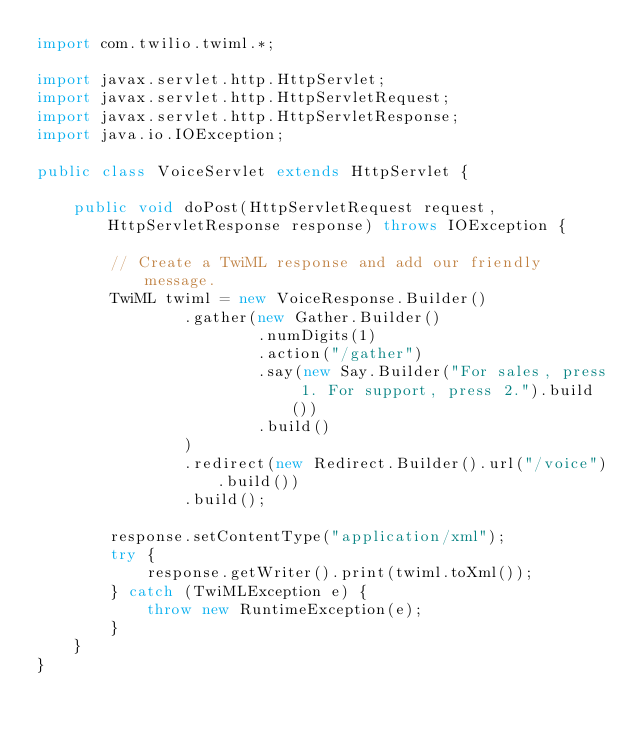Convert code to text. <code><loc_0><loc_0><loc_500><loc_500><_Java_>import com.twilio.twiml.*;

import javax.servlet.http.HttpServlet;
import javax.servlet.http.HttpServletRequest;
import javax.servlet.http.HttpServletResponse;
import java.io.IOException;

public class VoiceServlet extends HttpServlet {

    public void doPost(HttpServletRequest request, HttpServletResponse response) throws IOException {

        // Create a TwiML response and add our friendly message.
        TwiML twiml = new VoiceResponse.Builder()
                .gather(new Gather.Builder()
                        .numDigits(1)
                        .action("/gather")
                        .say(new Say.Builder("For sales, press 1. For support, press 2.").build())
                        .build()
                )
                .redirect(new Redirect.Builder().url("/voice").build())
                .build();

        response.setContentType("application/xml");
        try {
            response.getWriter().print(twiml.toXml());
        } catch (TwiMLException e) {
            throw new RuntimeException(e);
        }
    }
}
</code> 